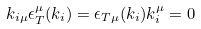Convert formula to latex. <formula><loc_0><loc_0><loc_500><loc_500>k _ { i \mu } \epsilon _ { T } ^ { \mu } ( k _ { i } ) = \epsilon _ { T \mu } ( k _ { i } ) k _ { i } ^ { \mu } = 0</formula> 